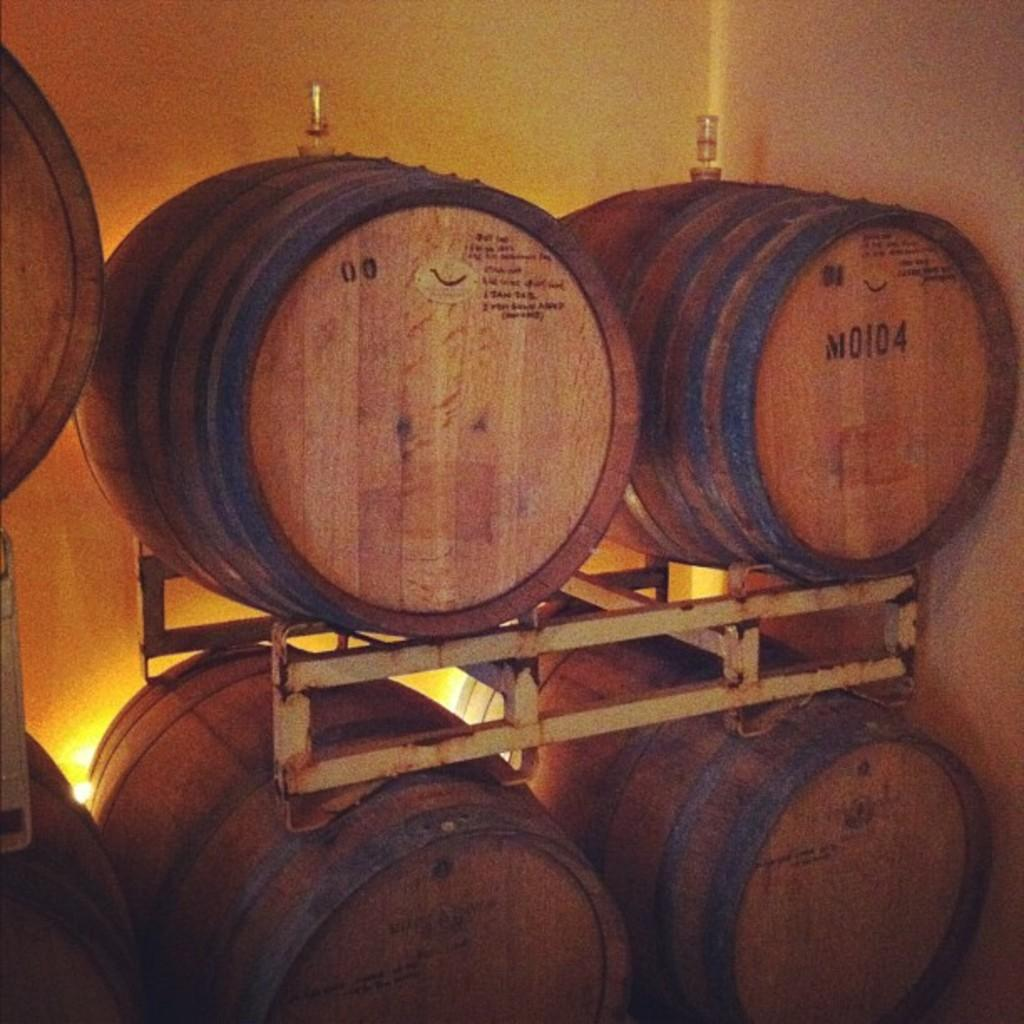What type of containers are visible in the image? There are wooden barrels in the image. What material is the metal object made of? The metal object in the image is made of metal. What can be seen in the background of the image? There is a wall in the background of the image. What type of frog can be seen sitting on top of the wooden barrels in the image? There is no frog present in the image; it only features wooden barrels and a metal object. What kind of pancake is being served on the wall in the image? There is no pancake present in the image; the wall is in the background and does not have any food items on it. 